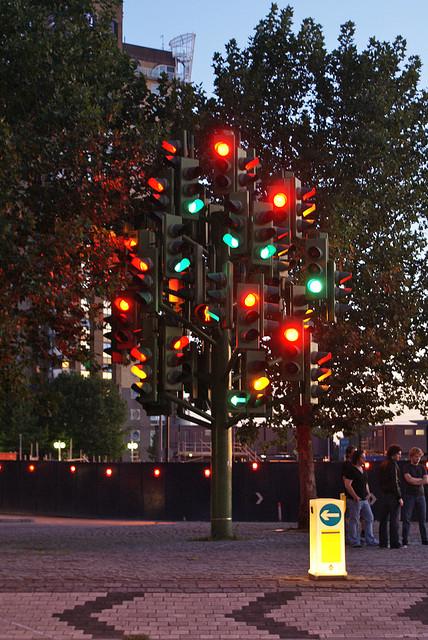What is the name of the business with the yellow sign?
Answer briefly. No business. Is it cloudy?
Write a very short answer. No. How many green lights are on?
Keep it brief. 7. How many pedestrians are here?
Be succinct. 4. Which way is the yellow arrow pointing?
Concise answer only. Left. 